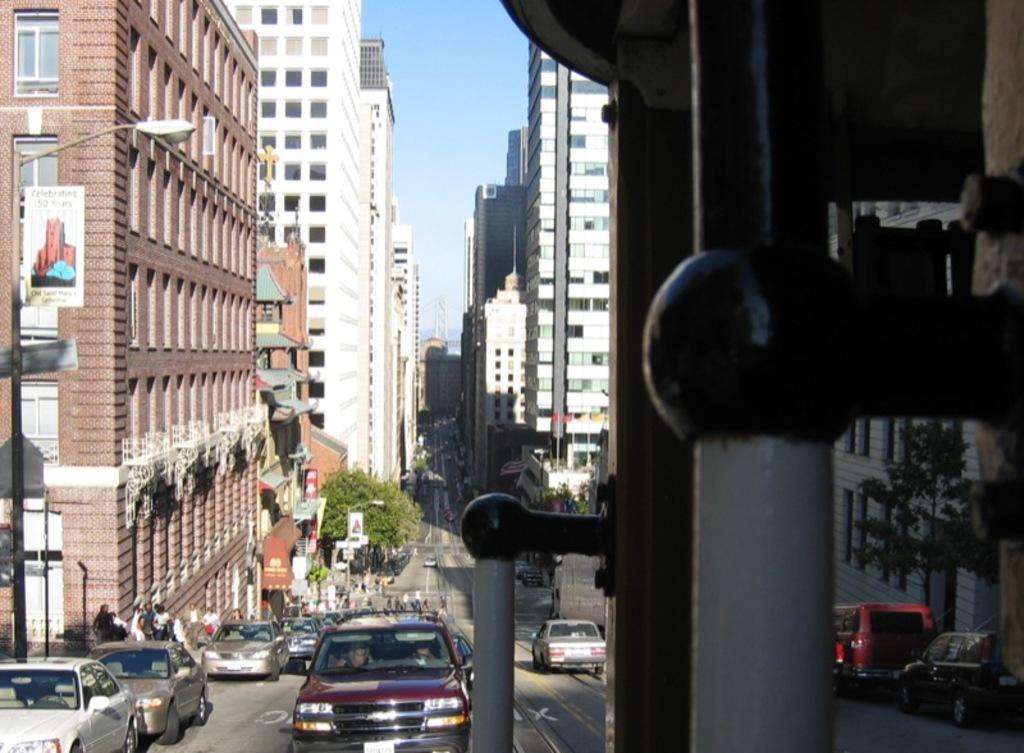Describe this image in one or two sentences. On the right side of the image there are rods. In the image there are vehicles on the road and also there are trees and buildings with walls and windows. There are poles with posters and sign boards. 